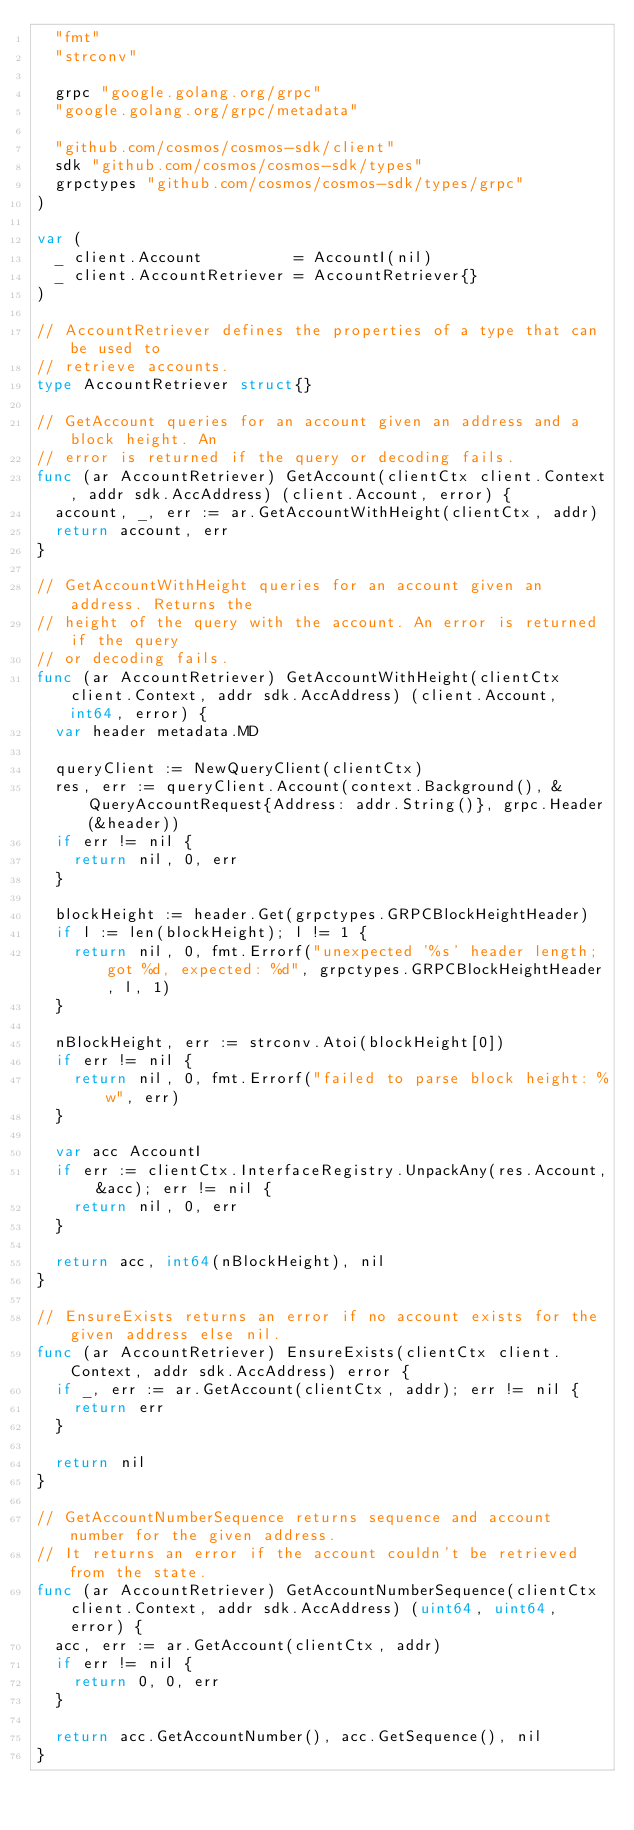<code> <loc_0><loc_0><loc_500><loc_500><_Go_>	"fmt"
	"strconv"

	grpc "google.golang.org/grpc"
	"google.golang.org/grpc/metadata"

	"github.com/cosmos/cosmos-sdk/client"
	sdk "github.com/cosmos/cosmos-sdk/types"
	grpctypes "github.com/cosmos/cosmos-sdk/types/grpc"
)

var (
	_ client.Account          = AccountI(nil)
	_ client.AccountRetriever = AccountRetriever{}
)

// AccountRetriever defines the properties of a type that can be used to
// retrieve accounts.
type AccountRetriever struct{}

// GetAccount queries for an account given an address and a block height. An
// error is returned if the query or decoding fails.
func (ar AccountRetriever) GetAccount(clientCtx client.Context, addr sdk.AccAddress) (client.Account, error) {
	account, _, err := ar.GetAccountWithHeight(clientCtx, addr)
	return account, err
}

// GetAccountWithHeight queries for an account given an address. Returns the
// height of the query with the account. An error is returned if the query
// or decoding fails.
func (ar AccountRetriever) GetAccountWithHeight(clientCtx client.Context, addr sdk.AccAddress) (client.Account, int64, error) {
	var header metadata.MD

	queryClient := NewQueryClient(clientCtx)
	res, err := queryClient.Account(context.Background(), &QueryAccountRequest{Address: addr.String()}, grpc.Header(&header))
	if err != nil {
		return nil, 0, err
	}

	blockHeight := header.Get(grpctypes.GRPCBlockHeightHeader)
	if l := len(blockHeight); l != 1 {
		return nil, 0, fmt.Errorf("unexpected '%s' header length; got %d, expected: %d", grpctypes.GRPCBlockHeightHeader, l, 1)
	}

	nBlockHeight, err := strconv.Atoi(blockHeight[0])
	if err != nil {
		return nil, 0, fmt.Errorf("failed to parse block height: %w", err)
	}

	var acc AccountI
	if err := clientCtx.InterfaceRegistry.UnpackAny(res.Account, &acc); err != nil {
		return nil, 0, err
	}

	return acc, int64(nBlockHeight), nil
}

// EnsureExists returns an error if no account exists for the given address else nil.
func (ar AccountRetriever) EnsureExists(clientCtx client.Context, addr sdk.AccAddress) error {
	if _, err := ar.GetAccount(clientCtx, addr); err != nil {
		return err
	}

	return nil
}

// GetAccountNumberSequence returns sequence and account number for the given address.
// It returns an error if the account couldn't be retrieved from the state.
func (ar AccountRetriever) GetAccountNumberSequence(clientCtx client.Context, addr sdk.AccAddress) (uint64, uint64, error) {
	acc, err := ar.GetAccount(clientCtx, addr)
	if err != nil {
		return 0, 0, err
	}

	return acc.GetAccountNumber(), acc.GetSequence(), nil
}
</code> 